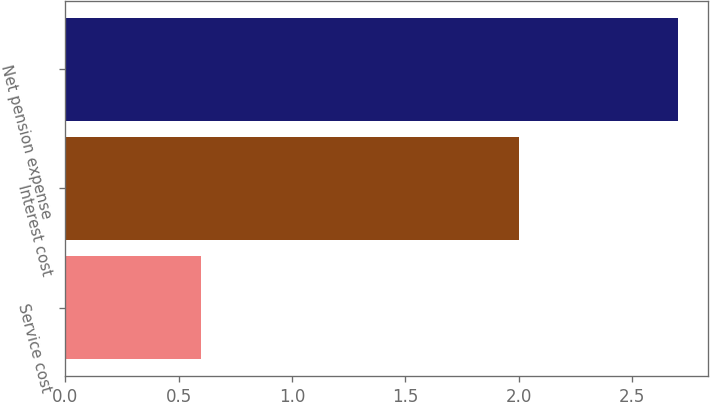Convert chart to OTSL. <chart><loc_0><loc_0><loc_500><loc_500><bar_chart><fcel>Service cost<fcel>Interest cost<fcel>Net pension expense<nl><fcel>0.6<fcel>2<fcel>2.7<nl></chart> 